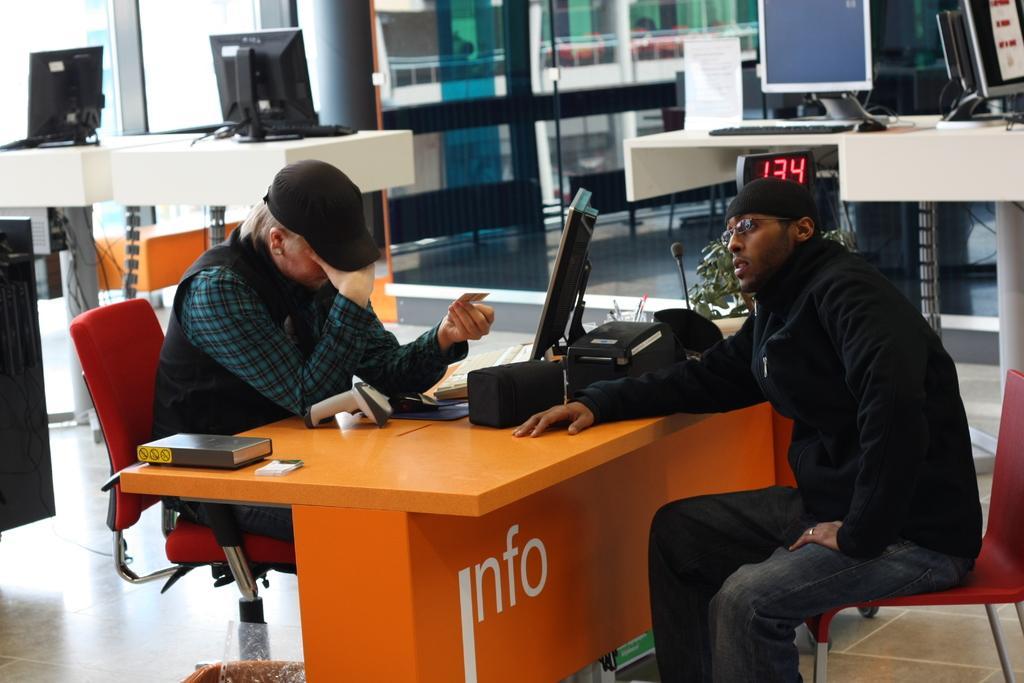Could you give a brief overview of what you see in this image? In this image on the right side there is one person who is sitting on a chair and he is wearing spectacles. On the left side there is one person who is sitting on a chair and she is holding a paper in front of them there is one table on that table there is one book, laptop, keyboard and printer and some pens are there. Beside the person there is one mike on the background there is a glass window and on the right side and left side of the image there are some systems. 